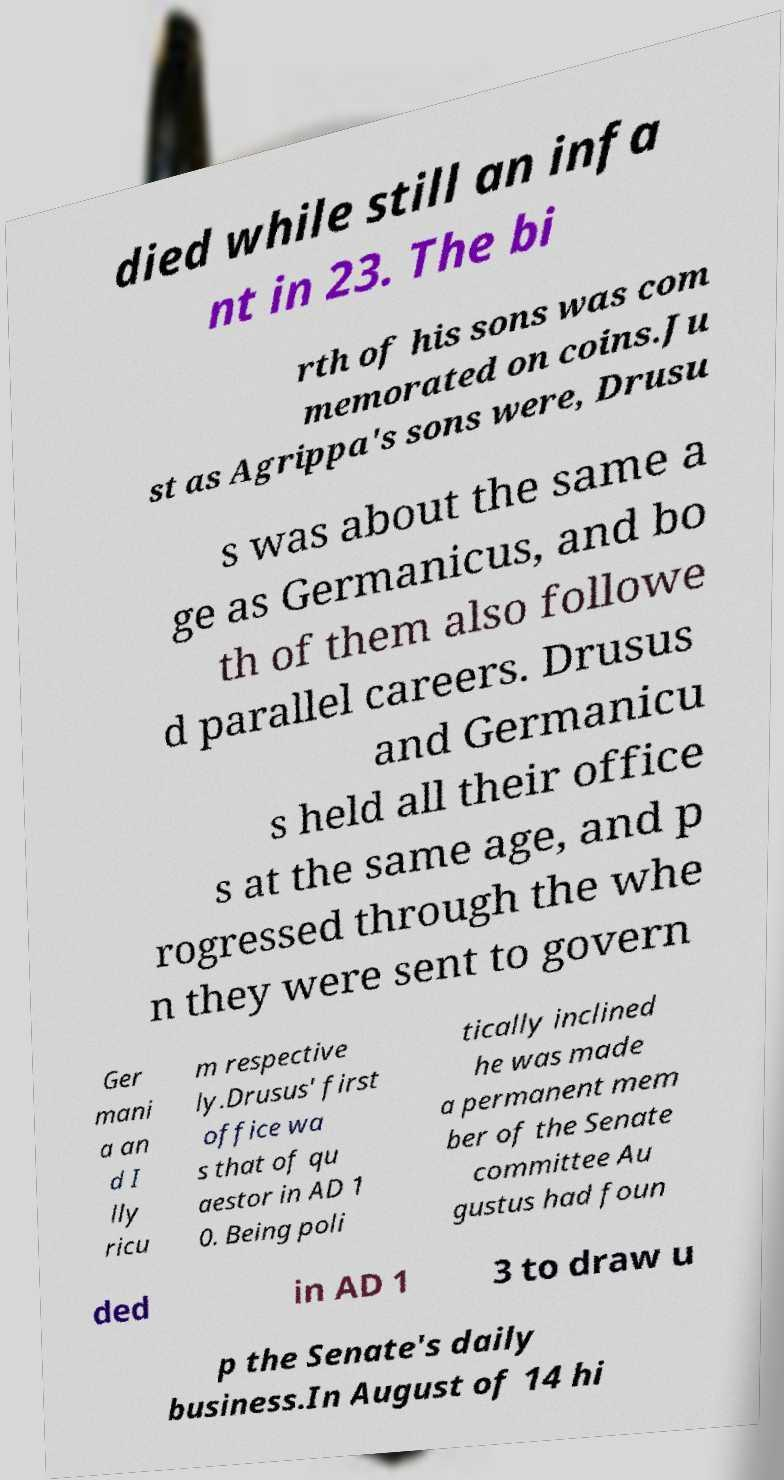Please read and relay the text visible in this image. What does it say? died while still an infa nt in 23. The bi rth of his sons was com memorated on coins.Ju st as Agrippa's sons were, Drusu s was about the same a ge as Germanicus, and bo th of them also followe d parallel careers. Drusus and Germanicu s held all their office s at the same age, and p rogressed through the whe n they were sent to govern Ger mani a an d I lly ricu m respective ly.Drusus' first office wa s that of qu aestor in AD 1 0. Being poli tically inclined he was made a permanent mem ber of the Senate committee Au gustus had foun ded in AD 1 3 to draw u p the Senate's daily business.In August of 14 hi 